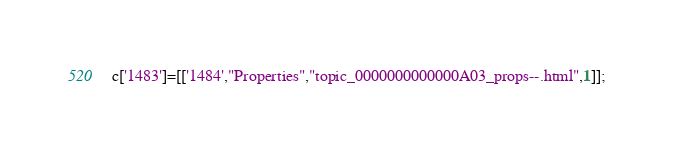<code> <loc_0><loc_0><loc_500><loc_500><_JavaScript_>c['1483']=[['1484',"Properties","topic_0000000000000A03_props--.html",1]];</code> 